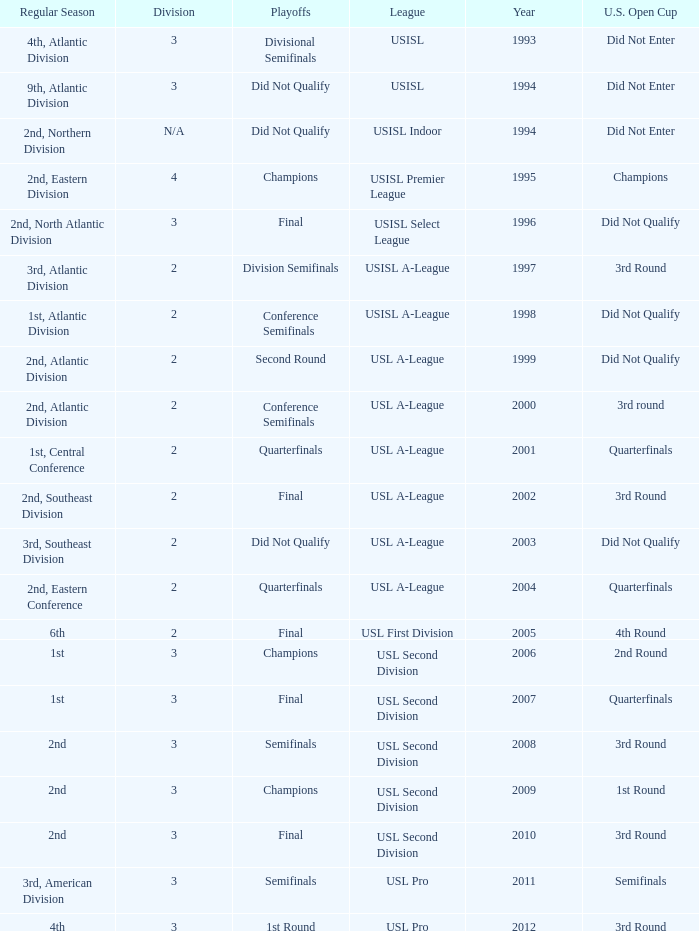What are all the playoffs for u.s. open cup in 1st round Champions. 